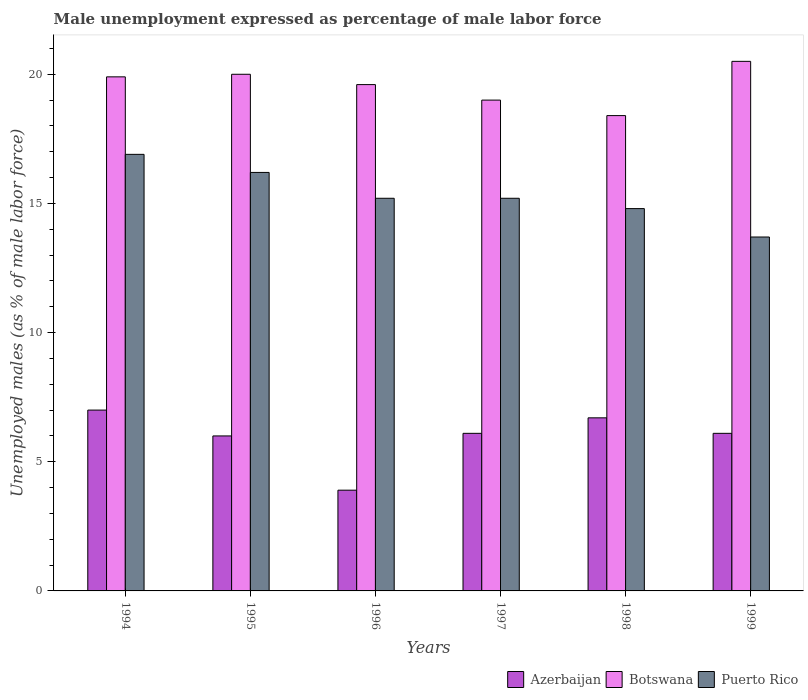How many groups of bars are there?
Your response must be concise. 6. Are the number of bars on each tick of the X-axis equal?
Your response must be concise. Yes. How many bars are there on the 2nd tick from the right?
Offer a very short reply. 3. What is the label of the 5th group of bars from the left?
Your answer should be very brief. 1998. What is the unemployment in males in in Puerto Rico in 1997?
Offer a terse response. 15.2. Across all years, what is the maximum unemployment in males in in Puerto Rico?
Your answer should be very brief. 16.9. Across all years, what is the minimum unemployment in males in in Puerto Rico?
Offer a very short reply. 13.7. What is the total unemployment in males in in Puerto Rico in the graph?
Your response must be concise. 92. What is the difference between the unemployment in males in in Puerto Rico in 1998 and that in 1999?
Offer a terse response. 1.1. What is the difference between the unemployment in males in in Puerto Rico in 1998 and the unemployment in males in in Botswana in 1999?
Ensure brevity in your answer.  -5.7. What is the average unemployment in males in in Azerbaijan per year?
Offer a terse response. 5.97. In the year 1995, what is the difference between the unemployment in males in in Puerto Rico and unemployment in males in in Botswana?
Your answer should be compact. -3.8. In how many years, is the unemployment in males in in Botswana greater than 15 %?
Provide a short and direct response. 6. What is the ratio of the unemployment in males in in Puerto Rico in 1995 to that in 1996?
Offer a very short reply. 1.07. Is the unemployment in males in in Botswana in 1995 less than that in 1996?
Make the answer very short. No. Is the difference between the unemployment in males in in Puerto Rico in 1997 and 1999 greater than the difference between the unemployment in males in in Botswana in 1997 and 1999?
Offer a very short reply. Yes. What is the difference between the highest and the second highest unemployment in males in in Botswana?
Keep it short and to the point. 0.5. What is the difference between the highest and the lowest unemployment in males in in Azerbaijan?
Your response must be concise. 3.1. Is the sum of the unemployment in males in in Puerto Rico in 1998 and 1999 greater than the maximum unemployment in males in in Botswana across all years?
Your answer should be compact. Yes. What does the 2nd bar from the left in 1997 represents?
Provide a succinct answer. Botswana. What does the 1st bar from the right in 1996 represents?
Provide a short and direct response. Puerto Rico. Are the values on the major ticks of Y-axis written in scientific E-notation?
Your answer should be very brief. No. Does the graph contain any zero values?
Your answer should be compact. No. Where does the legend appear in the graph?
Give a very brief answer. Bottom right. How many legend labels are there?
Give a very brief answer. 3. What is the title of the graph?
Your answer should be compact. Male unemployment expressed as percentage of male labor force. What is the label or title of the Y-axis?
Your response must be concise. Unemployed males (as % of male labor force). What is the Unemployed males (as % of male labor force) of Azerbaijan in 1994?
Your answer should be compact. 7. What is the Unemployed males (as % of male labor force) in Botswana in 1994?
Your answer should be very brief. 19.9. What is the Unemployed males (as % of male labor force) in Puerto Rico in 1994?
Make the answer very short. 16.9. What is the Unemployed males (as % of male labor force) of Azerbaijan in 1995?
Offer a terse response. 6. What is the Unemployed males (as % of male labor force) in Botswana in 1995?
Keep it short and to the point. 20. What is the Unemployed males (as % of male labor force) of Puerto Rico in 1995?
Your response must be concise. 16.2. What is the Unemployed males (as % of male labor force) of Azerbaijan in 1996?
Your answer should be very brief. 3.9. What is the Unemployed males (as % of male labor force) in Botswana in 1996?
Offer a very short reply. 19.6. What is the Unemployed males (as % of male labor force) of Puerto Rico in 1996?
Ensure brevity in your answer.  15.2. What is the Unemployed males (as % of male labor force) in Azerbaijan in 1997?
Provide a succinct answer. 6.1. What is the Unemployed males (as % of male labor force) of Botswana in 1997?
Offer a very short reply. 19. What is the Unemployed males (as % of male labor force) in Puerto Rico in 1997?
Offer a very short reply. 15.2. What is the Unemployed males (as % of male labor force) of Azerbaijan in 1998?
Give a very brief answer. 6.7. What is the Unemployed males (as % of male labor force) in Botswana in 1998?
Your answer should be compact. 18.4. What is the Unemployed males (as % of male labor force) in Puerto Rico in 1998?
Offer a very short reply. 14.8. What is the Unemployed males (as % of male labor force) of Azerbaijan in 1999?
Offer a very short reply. 6.1. What is the Unemployed males (as % of male labor force) in Botswana in 1999?
Provide a short and direct response. 20.5. What is the Unemployed males (as % of male labor force) of Puerto Rico in 1999?
Your answer should be very brief. 13.7. Across all years, what is the maximum Unemployed males (as % of male labor force) of Botswana?
Offer a terse response. 20.5. Across all years, what is the maximum Unemployed males (as % of male labor force) in Puerto Rico?
Keep it short and to the point. 16.9. Across all years, what is the minimum Unemployed males (as % of male labor force) in Azerbaijan?
Provide a short and direct response. 3.9. Across all years, what is the minimum Unemployed males (as % of male labor force) in Botswana?
Keep it short and to the point. 18.4. Across all years, what is the minimum Unemployed males (as % of male labor force) in Puerto Rico?
Keep it short and to the point. 13.7. What is the total Unemployed males (as % of male labor force) in Azerbaijan in the graph?
Offer a terse response. 35.8. What is the total Unemployed males (as % of male labor force) of Botswana in the graph?
Provide a short and direct response. 117.4. What is the total Unemployed males (as % of male labor force) of Puerto Rico in the graph?
Offer a terse response. 92. What is the difference between the Unemployed males (as % of male labor force) in Botswana in 1994 and that in 1996?
Offer a very short reply. 0.3. What is the difference between the Unemployed males (as % of male labor force) of Azerbaijan in 1994 and that in 1997?
Your response must be concise. 0.9. What is the difference between the Unemployed males (as % of male labor force) of Puerto Rico in 1994 and that in 1997?
Provide a succinct answer. 1.7. What is the difference between the Unemployed males (as % of male labor force) in Azerbaijan in 1994 and that in 1998?
Offer a very short reply. 0.3. What is the difference between the Unemployed males (as % of male labor force) of Puerto Rico in 1994 and that in 1998?
Offer a terse response. 2.1. What is the difference between the Unemployed males (as % of male labor force) of Botswana in 1994 and that in 1999?
Keep it short and to the point. -0.6. What is the difference between the Unemployed males (as % of male labor force) of Puerto Rico in 1995 and that in 1996?
Offer a terse response. 1. What is the difference between the Unemployed males (as % of male labor force) in Botswana in 1995 and that in 1997?
Provide a succinct answer. 1. What is the difference between the Unemployed males (as % of male labor force) of Puerto Rico in 1995 and that in 1997?
Your answer should be very brief. 1. What is the difference between the Unemployed males (as % of male labor force) in Azerbaijan in 1995 and that in 1998?
Provide a succinct answer. -0.7. What is the difference between the Unemployed males (as % of male labor force) of Puerto Rico in 1995 and that in 1998?
Give a very brief answer. 1.4. What is the difference between the Unemployed males (as % of male labor force) in Botswana in 1995 and that in 1999?
Offer a very short reply. -0.5. What is the difference between the Unemployed males (as % of male labor force) in Puerto Rico in 1996 and that in 1997?
Offer a terse response. 0. What is the difference between the Unemployed males (as % of male labor force) in Azerbaijan in 1996 and that in 1998?
Your answer should be compact. -2.8. What is the difference between the Unemployed males (as % of male labor force) in Azerbaijan in 1996 and that in 1999?
Ensure brevity in your answer.  -2.2. What is the difference between the Unemployed males (as % of male labor force) of Puerto Rico in 1996 and that in 1999?
Give a very brief answer. 1.5. What is the difference between the Unemployed males (as % of male labor force) in Botswana in 1997 and that in 1998?
Give a very brief answer. 0.6. What is the difference between the Unemployed males (as % of male labor force) in Botswana in 1997 and that in 1999?
Give a very brief answer. -1.5. What is the difference between the Unemployed males (as % of male labor force) of Puerto Rico in 1997 and that in 1999?
Provide a short and direct response. 1.5. What is the difference between the Unemployed males (as % of male labor force) in Botswana in 1998 and that in 1999?
Make the answer very short. -2.1. What is the difference between the Unemployed males (as % of male labor force) of Puerto Rico in 1998 and that in 1999?
Give a very brief answer. 1.1. What is the difference between the Unemployed males (as % of male labor force) of Azerbaijan in 1994 and the Unemployed males (as % of male labor force) of Puerto Rico in 1995?
Your response must be concise. -9.2. What is the difference between the Unemployed males (as % of male labor force) of Azerbaijan in 1994 and the Unemployed males (as % of male labor force) of Botswana in 1996?
Offer a very short reply. -12.6. What is the difference between the Unemployed males (as % of male labor force) of Azerbaijan in 1994 and the Unemployed males (as % of male labor force) of Puerto Rico in 1996?
Keep it short and to the point. -8.2. What is the difference between the Unemployed males (as % of male labor force) of Azerbaijan in 1994 and the Unemployed males (as % of male labor force) of Botswana in 1997?
Give a very brief answer. -12. What is the difference between the Unemployed males (as % of male labor force) in Azerbaijan in 1994 and the Unemployed males (as % of male labor force) in Puerto Rico in 1997?
Your answer should be very brief. -8.2. What is the difference between the Unemployed males (as % of male labor force) in Azerbaijan in 1994 and the Unemployed males (as % of male labor force) in Botswana in 1998?
Keep it short and to the point. -11.4. What is the difference between the Unemployed males (as % of male labor force) in Azerbaijan in 1994 and the Unemployed males (as % of male labor force) in Puerto Rico in 1998?
Provide a succinct answer. -7.8. What is the difference between the Unemployed males (as % of male labor force) of Azerbaijan in 1995 and the Unemployed males (as % of male labor force) of Botswana in 1996?
Keep it short and to the point. -13.6. What is the difference between the Unemployed males (as % of male labor force) in Azerbaijan in 1995 and the Unemployed males (as % of male labor force) in Puerto Rico in 1996?
Give a very brief answer. -9.2. What is the difference between the Unemployed males (as % of male labor force) in Botswana in 1995 and the Unemployed males (as % of male labor force) in Puerto Rico in 1996?
Give a very brief answer. 4.8. What is the difference between the Unemployed males (as % of male labor force) of Azerbaijan in 1995 and the Unemployed males (as % of male labor force) of Puerto Rico in 1997?
Give a very brief answer. -9.2. What is the difference between the Unemployed males (as % of male labor force) in Azerbaijan in 1995 and the Unemployed males (as % of male labor force) in Puerto Rico in 1998?
Your answer should be very brief. -8.8. What is the difference between the Unemployed males (as % of male labor force) in Azerbaijan in 1995 and the Unemployed males (as % of male labor force) in Puerto Rico in 1999?
Give a very brief answer. -7.7. What is the difference between the Unemployed males (as % of male labor force) in Botswana in 1995 and the Unemployed males (as % of male labor force) in Puerto Rico in 1999?
Offer a terse response. 6.3. What is the difference between the Unemployed males (as % of male labor force) of Azerbaijan in 1996 and the Unemployed males (as % of male labor force) of Botswana in 1997?
Ensure brevity in your answer.  -15.1. What is the difference between the Unemployed males (as % of male labor force) of Azerbaijan in 1996 and the Unemployed males (as % of male labor force) of Puerto Rico in 1997?
Your answer should be compact. -11.3. What is the difference between the Unemployed males (as % of male labor force) of Botswana in 1996 and the Unemployed males (as % of male labor force) of Puerto Rico in 1997?
Your answer should be compact. 4.4. What is the difference between the Unemployed males (as % of male labor force) of Azerbaijan in 1996 and the Unemployed males (as % of male labor force) of Botswana in 1999?
Your answer should be very brief. -16.6. What is the difference between the Unemployed males (as % of male labor force) in Azerbaijan in 1997 and the Unemployed males (as % of male labor force) in Botswana in 1998?
Offer a terse response. -12.3. What is the difference between the Unemployed males (as % of male labor force) in Azerbaijan in 1997 and the Unemployed males (as % of male labor force) in Puerto Rico in 1998?
Keep it short and to the point. -8.7. What is the difference between the Unemployed males (as % of male labor force) of Azerbaijan in 1997 and the Unemployed males (as % of male labor force) of Botswana in 1999?
Provide a succinct answer. -14.4. What is the difference between the Unemployed males (as % of male labor force) of Azerbaijan in 1997 and the Unemployed males (as % of male labor force) of Puerto Rico in 1999?
Offer a very short reply. -7.6. What is the difference between the Unemployed males (as % of male labor force) of Botswana in 1998 and the Unemployed males (as % of male labor force) of Puerto Rico in 1999?
Ensure brevity in your answer.  4.7. What is the average Unemployed males (as % of male labor force) of Azerbaijan per year?
Keep it short and to the point. 5.97. What is the average Unemployed males (as % of male labor force) of Botswana per year?
Your answer should be compact. 19.57. What is the average Unemployed males (as % of male labor force) of Puerto Rico per year?
Provide a short and direct response. 15.33. In the year 1994, what is the difference between the Unemployed males (as % of male labor force) of Botswana and Unemployed males (as % of male labor force) of Puerto Rico?
Your answer should be very brief. 3. In the year 1995, what is the difference between the Unemployed males (as % of male labor force) in Azerbaijan and Unemployed males (as % of male labor force) in Botswana?
Make the answer very short. -14. In the year 1996, what is the difference between the Unemployed males (as % of male labor force) of Azerbaijan and Unemployed males (as % of male labor force) of Botswana?
Provide a short and direct response. -15.7. In the year 1996, what is the difference between the Unemployed males (as % of male labor force) in Azerbaijan and Unemployed males (as % of male labor force) in Puerto Rico?
Offer a very short reply. -11.3. In the year 1996, what is the difference between the Unemployed males (as % of male labor force) of Botswana and Unemployed males (as % of male labor force) of Puerto Rico?
Offer a very short reply. 4.4. In the year 1997, what is the difference between the Unemployed males (as % of male labor force) of Azerbaijan and Unemployed males (as % of male labor force) of Botswana?
Ensure brevity in your answer.  -12.9. In the year 1997, what is the difference between the Unemployed males (as % of male labor force) in Botswana and Unemployed males (as % of male labor force) in Puerto Rico?
Your answer should be very brief. 3.8. In the year 1998, what is the difference between the Unemployed males (as % of male labor force) of Azerbaijan and Unemployed males (as % of male labor force) of Puerto Rico?
Offer a very short reply. -8.1. In the year 1998, what is the difference between the Unemployed males (as % of male labor force) of Botswana and Unemployed males (as % of male labor force) of Puerto Rico?
Your answer should be very brief. 3.6. In the year 1999, what is the difference between the Unemployed males (as % of male labor force) of Azerbaijan and Unemployed males (as % of male labor force) of Botswana?
Make the answer very short. -14.4. What is the ratio of the Unemployed males (as % of male labor force) of Azerbaijan in 1994 to that in 1995?
Provide a short and direct response. 1.17. What is the ratio of the Unemployed males (as % of male labor force) of Puerto Rico in 1994 to that in 1995?
Offer a very short reply. 1.04. What is the ratio of the Unemployed males (as % of male labor force) of Azerbaijan in 1994 to that in 1996?
Give a very brief answer. 1.79. What is the ratio of the Unemployed males (as % of male labor force) of Botswana in 1994 to that in 1996?
Provide a succinct answer. 1.02. What is the ratio of the Unemployed males (as % of male labor force) of Puerto Rico in 1994 to that in 1996?
Give a very brief answer. 1.11. What is the ratio of the Unemployed males (as % of male labor force) of Azerbaijan in 1994 to that in 1997?
Offer a very short reply. 1.15. What is the ratio of the Unemployed males (as % of male labor force) of Botswana in 1994 to that in 1997?
Provide a short and direct response. 1.05. What is the ratio of the Unemployed males (as % of male labor force) of Puerto Rico in 1994 to that in 1997?
Offer a very short reply. 1.11. What is the ratio of the Unemployed males (as % of male labor force) in Azerbaijan in 1994 to that in 1998?
Provide a succinct answer. 1.04. What is the ratio of the Unemployed males (as % of male labor force) in Botswana in 1994 to that in 1998?
Offer a terse response. 1.08. What is the ratio of the Unemployed males (as % of male labor force) of Puerto Rico in 1994 to that in 1998?
Offer a terse response. 1.14. What is the ratio of the Unemployed males (as % of male labor force) in Azerbaijan in 1994 to that in 1999?
Give a very brief answer. 1.15. What is the ratio of the Unemployed males (as % of male labor force) of Botswana in 1994 to that in 1999?
Make the answer very short. 0.97. What is the ratio of the Unemployed males (as % of male labor force) in Puerto Rico in 1994 to that in 1999?
Offer a very short reply. 1.23. What is the ratio of the Unemployed males (as % of male labor force) in Azerbaijan in 1995 to that in 1996?
Provide a short and direct response. 1.54. What is the ratio of the Unemployed males (as % of male labor force) in Botswana in 1995 to that in 1996?
Your answer should be very brief. 1.02. What is the ratio of the Unemployed males (as % of male labor force) in Puerto Rico in 1995 to that in 1996?
Make the answer very short. 1.07. What is the ratio of the Unemployed males (as % of male labor force) in Azerbaijan in 1995 to that in 1997?
Provide a succinct answer. 0.98. What is the ratio of the Unemployed males (as % of male labor force) of Botswana in 1995 to that in 1997?
Your answer should be compact. 1.05. What is the ratio of the Unemployed males (as % of male labor force) of Puerto Rico in 1995 to that in 1997?
Ensure brevity in your answer.  1.07. What is the ratio of the Unemployed males (as % of male labor force) of Azerbaijan in 1995 to that in 1998?
Provide a short and direct response. 0.9. What is the ratio of the Unemployed males (as % of male labor force) in Botswana in 1995 to that in 1998?
Make the answer very short. 1.09. What is the ratio of the Unemployed males (as % of male labor force) of Puerto Rico in 1995 to that in 1998?
Your response must be concise. 1.09. What is the ratio of the Unemployed males (as % of male labor force) in Azerbaijan in 1995 to that in 1999?
Provide a succinct answer. 0.98. What is the ratio of the Unemployed males (as % of male labor force) of Botswana in 1995 to that in 1999?
Give a very brief answer. 0.98. What is the ratio of the Unemployed males (as % of male labor force) in Puerto Rico in 1995 to that in 1999?
Provide a succinct answer. 1.18. What is the ratio of the Unemployed males (as % of male labor force) in Azerbaijan in 1996 to that in 1997?
Provide a short and direct response. 0.64. What is the ratio of the Unemployed males (as % of male labor force) in Botswana in 1996 to that in 1997?
Your response must be concise. 1.03. What is the ratio of the Unemployed males (as % of male labor force) of Azerbaijan in 1996 to that in 1998?
Keep it short and to the point. 0.58. What is the ratio of the Unemployed males (as % of male labor force) in Botswana in 1996 to that in 1998?
Provide a succinct answer. 1.07. What is the ratio of the Unemployed males (as % of male labor force) of Azerbaijan in 1996 to that in 1999?
Provide a short and direct response. 0.64. What is the ratio of the Unemployed males (as % of male labor force) in Botswana in 1996 to that in 1999?
Offer a terse response. 0.96. What is the ratio of the Unemployed males (as % of male labor force) in Puerto Rico in 1996 to that in 1999?
Your answer should be compact. 1.11. What is the ratio of the Unemployed males (as % of male labor force) in Azerbaijan in 1997 to that in 1998?
Make the answer very short. 0.91. What is the ratio of the Unemployed males (as % of male labor force) in Botswana in 1997 to that in 1998?
Ensure brevity in your answer.  1.03. What is the ratio of the Unemployed males (as % of male labor force) of Puerto Rico in 1997 to that in 1998?
Keep it short and to the point. 1.03. What is the ratio of the Unemployed males (as % of male labor force) of Azerbaijan in 1997 to that in 1999?
Ensure brevity in your answer.  1. What is the ratio of the Unemployed males (as % of male labor force) of Botswana in 1997 to that in 1999?
Your answer should be very brief. 0.93. What is the ratio of the Unemployed males (as % of male labor force) in Puerto Rico in 1997 to that in 1999?
Ensure brevity in your answer.  1.11. What is the ratio of the Unemployed males (as % of male labor force) of Azerbaijan in 1998 to that in 1999?
Give a very brief answer. 1.1. What is the ratio of the Unemployed males (as % of male labor force) of Botswana in 1998 to that in 1999?
Give a very brief answer. 0.9. What is the ratio of the Unemployed males (as % of male labor force) of Puerto Rico in 1998 to that in 1999?
Provide a succinct answer. 1.08. What is the difference between the highest and the second highest Unemployed males (as % of male labor force) in Azerbaijan?
Make the answer very short. 0.3. What is the difference between the highest and the lowest Unemployed males (as % of male labor force) of Puerto Rico?
Keep it short and to the point. 3.2. 